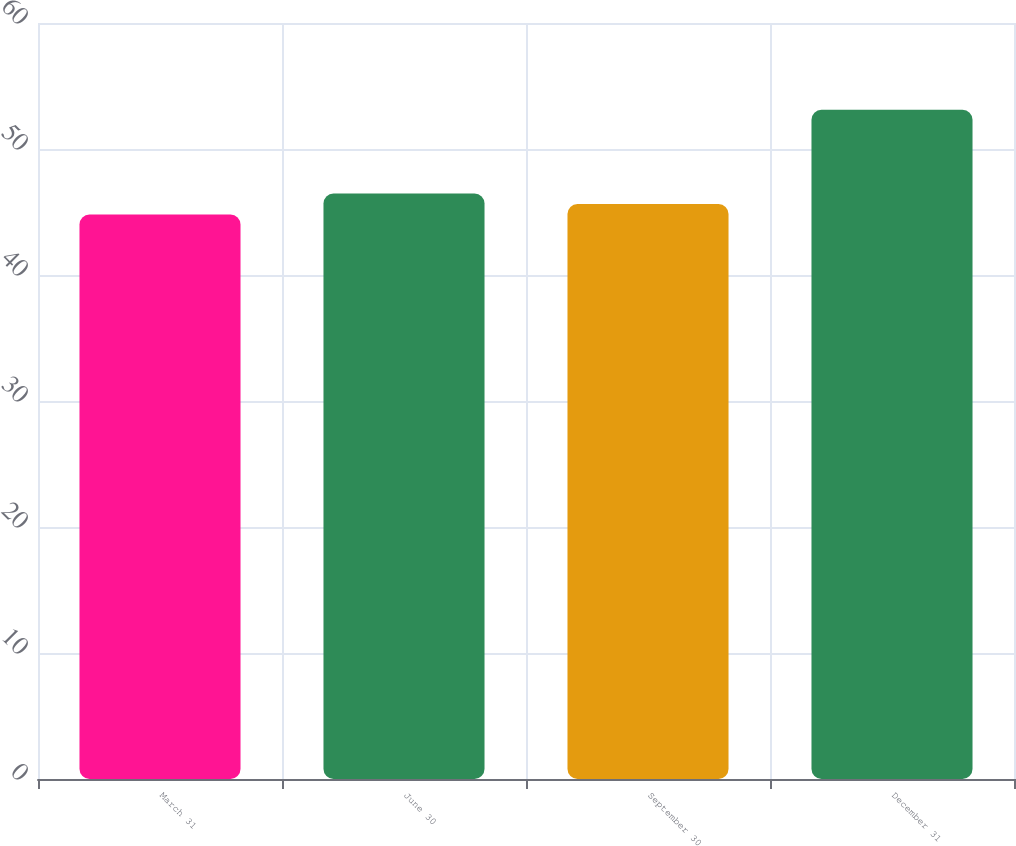Convert chart. <chart><loc_0><loc_0><loc_500><loc_500><bar_chart><fcel>March 31<fcel>June 30<fcel>September 30<fcel>December 31<nl><fcel>44.8<fcel>46.46<fcel>45.63<fcel>53.11<nl></chart> 